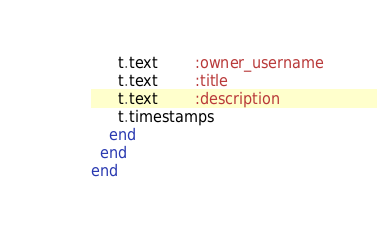<code> <loc_0><loc_0><loc_500><loc_500><_Ruby_>      t.text        :owner_username
      t.text        :title
      t.text        :description
      t.timestamps
    end
  end
end
</code> 